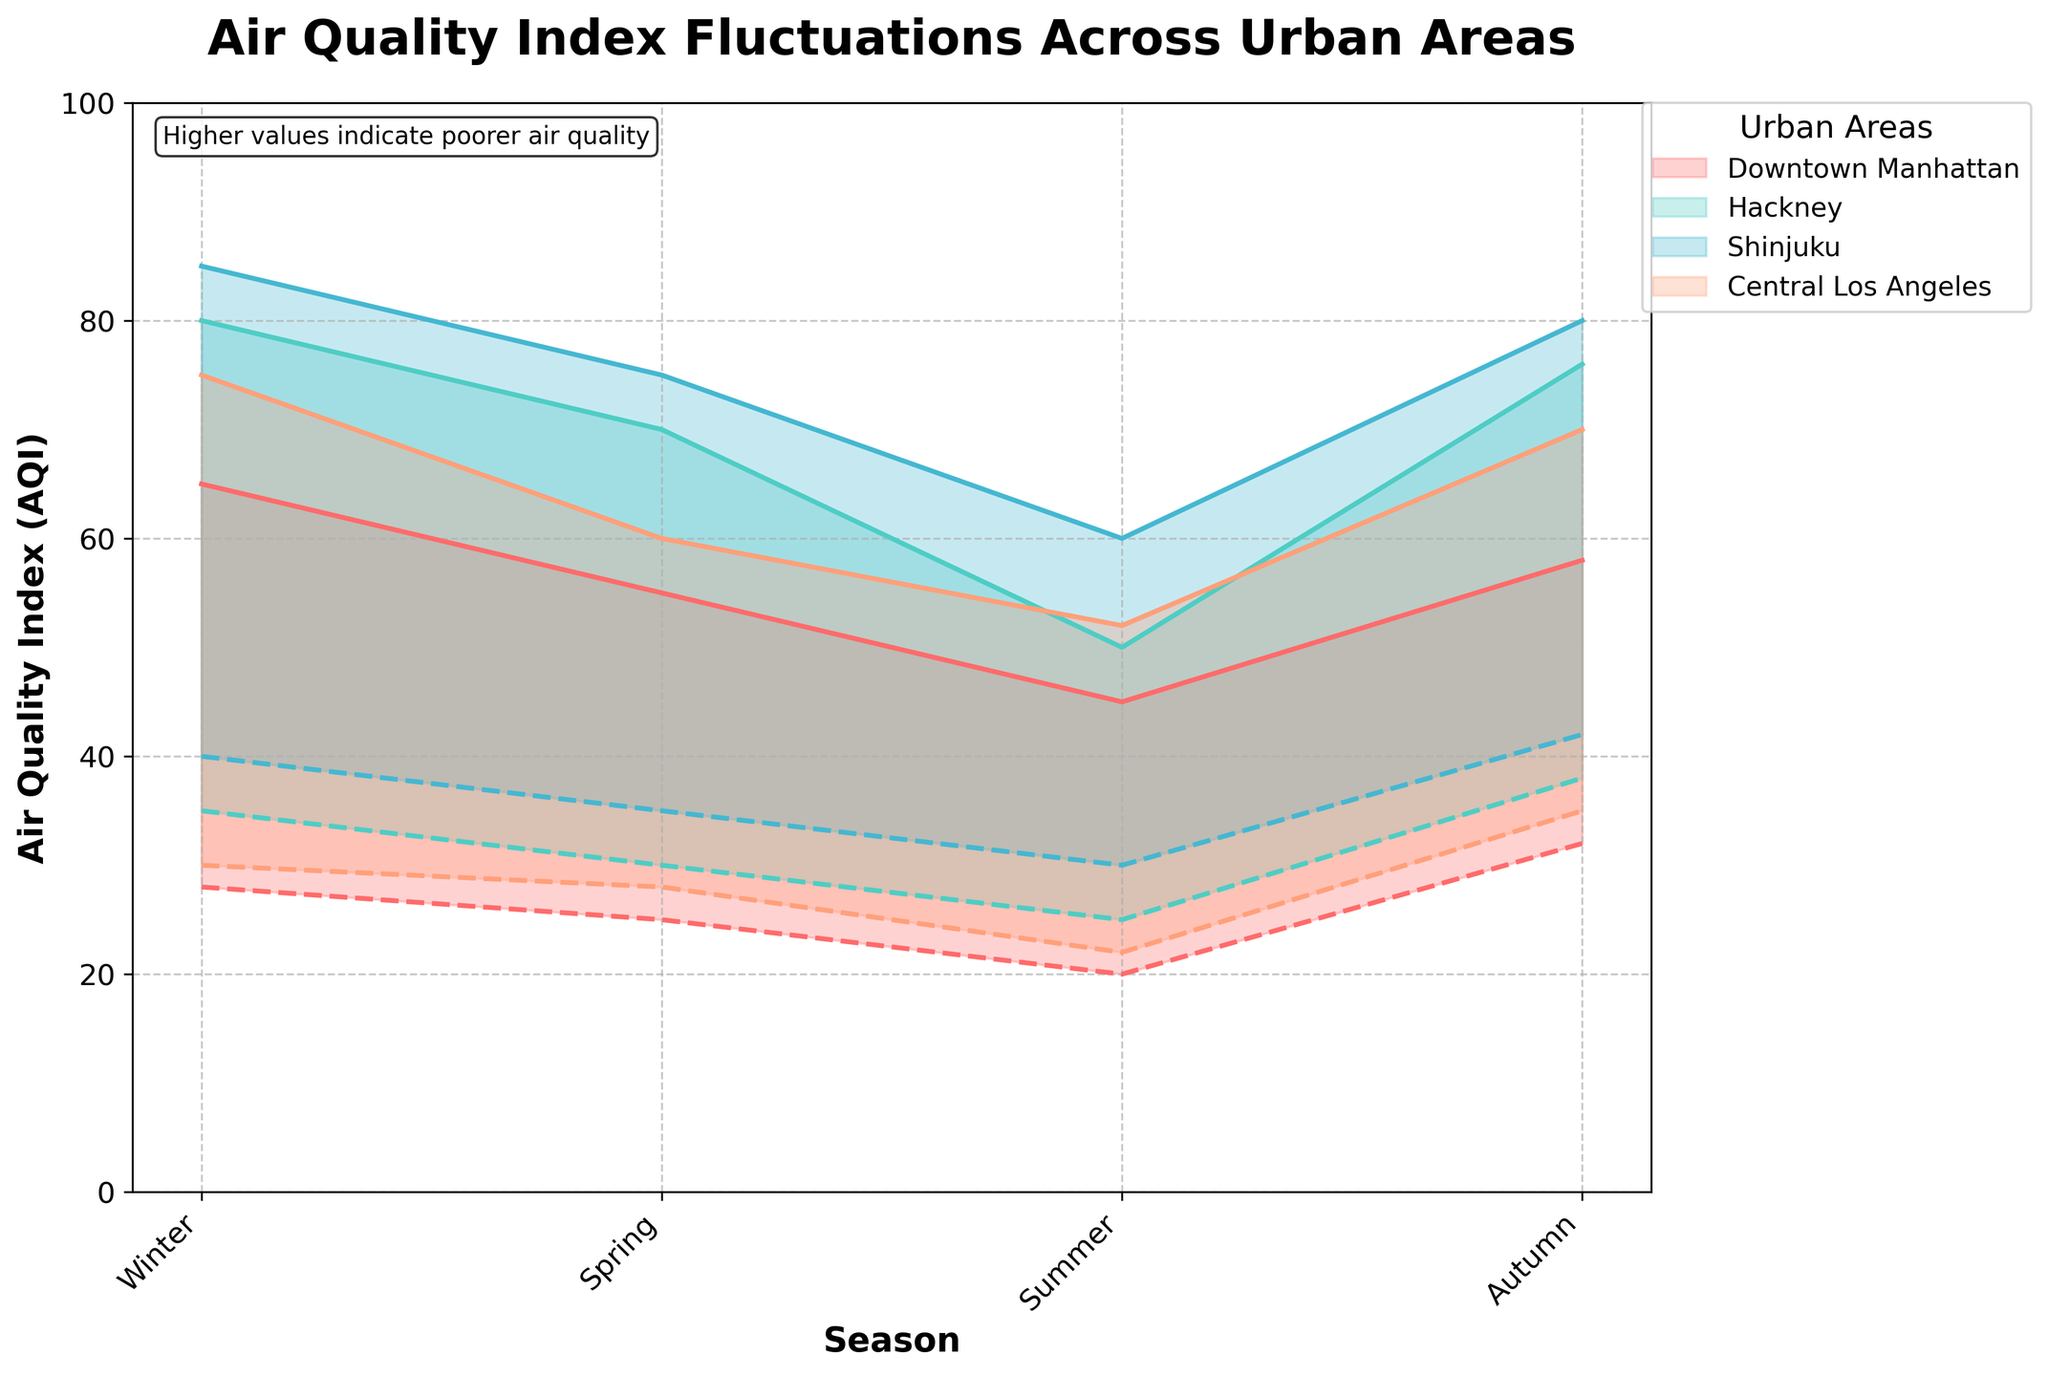What is the title of the chart? The title is typically positioned at the top of the chart and is in bold font. The title reads, "Air Quality Index Fluctuations Across Urban Areas."
Answer: Air Quality Index Fluctuations Across Urban Areas Which season has the highest maximum AQI in Shinjuku? To determine this, inspect the maximum values for Shinjuku across all seasons. The highest value is in the Autumn with an AQI of 80.
Answer: Autumn What is the range of AQI values for Downtown Manhattan in Summer? The range can be found by noting the minimum and maximum AQI values for Downtown Manhattan in Summer. The values are 20 and 45, giving a range of 25.
Answer: 25 In which season does Hackney have the widest fluctuation in AQI values? Compare the difference between maximum and minimum AQI values for Hackney across all seasons. The widest fluctuation is in Winter with a range from 35 to 80.
Answer: Winter Which urban area has the lowest minimum AQI in Spring? Compare the minimum AQI values for all the urban areas in Spring. Downtown Manhattan has the lowest minimum AQI of 25.
Answer: Downtown Manhattan How do the AQI values for Central Los Angeles in Winter compare to those in Autumn? While in Winter, the AQI ranges from 30 to 75, in Autumn it ranges from 35 to 70. Winter has a broader range and a higher maximum AQI.
Answer: Winter has a broader range and higher max AQI What is the general trend in AQI values from Winter to Summer for all areas? Observing the trend lines from Winter to Summer, it is seen that the AQI values generally decrease for all areas.
Answer: Decreasing What is the average maximum AQI for all areas in Winter? Add the maximum AQI values for Winter (65 + 80 + 85 + 75) and divide by the number of areas (4). The average is (305/4) = 76.25.
Answer: 76.25 Which urban area shows the least variation in AQI over all seasons? Compare the ranges for each area across all seasons. Downtown Manhattan has the smallest variations in AQI values.
Answer: Downtown Manhattan What color represents the AQI values for Hackney in the chart? Each area is represented by a distinct color. Hackney is shown with a specific color that is typically listed in the legend. The chosen color is teal.
Answer: Teal 